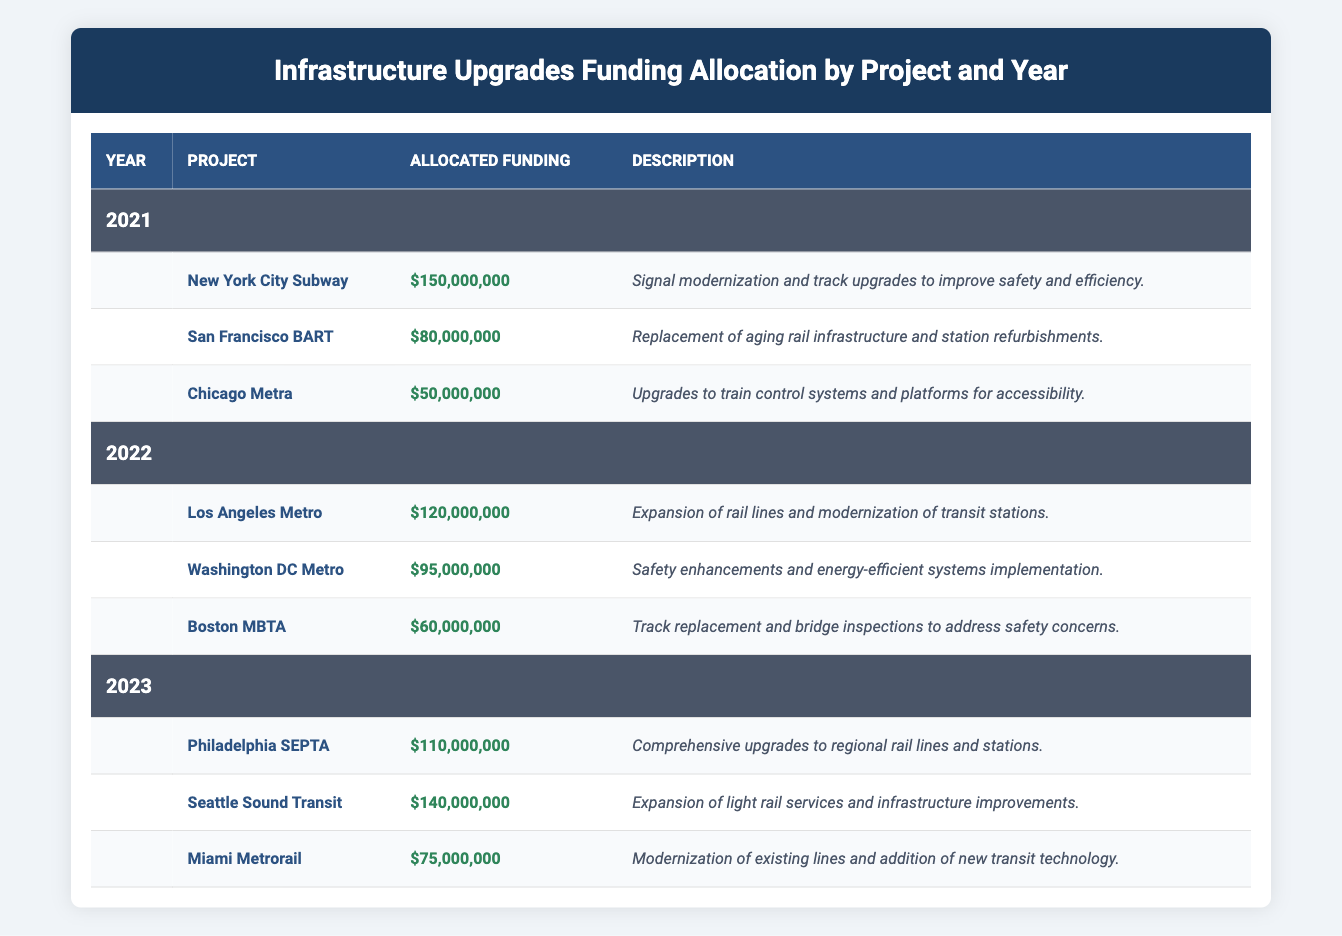What is the total allocated funding for the New York City Subway in 2021? The allocated funding for the New York City Subway in 2021 is specified in the table as $150,000,000.
Answer: 150,000,000 Which project received the highest allocated funding in 2023? In the year 2023, the Seattle Sound Transit project received the highest allocated funding of $140,000,000, which can be determined by comparing all the funding values listed for that year.
Answer: Seattle Sound Transit What is the average allocated funding for the Boston MBTA across 2022? Boston MBTA received an allocated funding of $60,000,000 in 2022. Since it is the only entry for that project for the year, the average is simply $60,000,000 divided by 1, which is $60,000,000.
Answer: 60,000,000 Did the San Francisco BART receive more funding than the Miami Metrorail in their respective years? San Francisco BART received $80,000,000 in 2021, and Miami Metrorail received $75,000,000 in 2023. Since $80,000,000 is greater than $75,000,000, the answer is yes.
Answer: Yes What is the total allocated funding for infrastructure upgrades across all projects in 2022? To find the total funding for 2022, add the allocated funds: Los Angeles Metro ($120,000,000) + Washington DC Metro ($95,000,000) + Boston MBTA ($60,000,000) = $120,000,000 + $95,000,000 + $60,000,000 = $275,000,000.
Answer: 275,000,000 How many projects received allocated funding greater than $100,000,000 in 2021? Only the New York City Subway ($150,000,000) received allocated funding greater than $100,000,000 in 2021. There are no other projects for that year with funding above $100,000,000.
Answer: 1 What is the difference in allocated funding between the Los Angeles Metro and the Washington DC Metro in 2022? The Los Angeles Metro received $120,000,000, and the Washington DC Metro received $95,000,000. The difference is $120,000,000 - $95,000,000 = $25,000,000.
Answer: 25,000,000 Is the allocated funding for the Philadelphia SEPTA in 2023 greater than the sum of the funding for the Chicago Metra and Boston MBTA combined? Philadelphia SEPTA received $110,000,000, while Chicago Metra received $50,000,000 and Boston MBTA received $60,000,000. The sum is $50,000,000 + $60,000,000 = $110,000,000. Since $110,000,000 is equal to $110,000,000, the answer is no.
Answer: No 